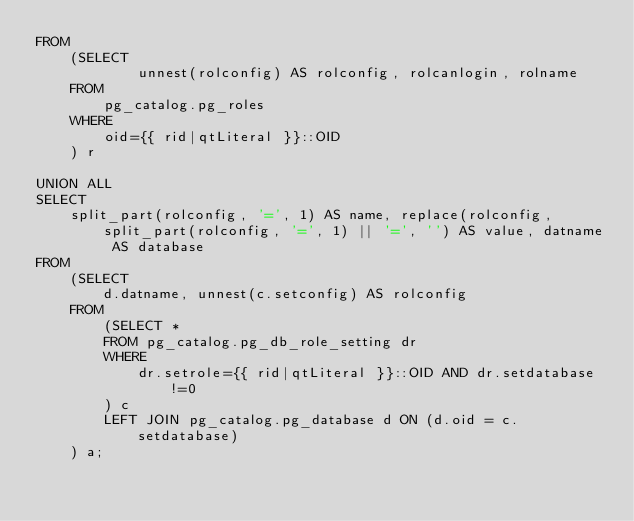<code> <loc_0><loc_0><loc_500><loc_500><_SQL_>FROM
    (SELECT
            unnest(rolconfig) AS rolconfig, rolcanlogin, rolname
    FROM
        pg_catalog.pg_roles
    WHERE
        oid={{ rid|qtLiteral }}::OID
    ) r

UNION ALL
SELECT
    split_part(rolconfig, '=', 1) AS name, replace(rolconfig, split_part(rolconfig, '=', 1) || '=', '') AS value, datname AS database
FROM
    (SELECT
        d.datname, unnest(c.setconfig) AS rolconfig
    FROM
        (SELECT *
        FROM pg_catalog.pg_db_role_setting dr
        WHERE
            dr.setrole={{ rid|qtLiteral }}::OID AND dr.setdatabase!=0
        ) c
        LEFT JOIN pg_catalog.pg_database d ON (d.oid = c.setdatabase)
    ) a;
</code> 